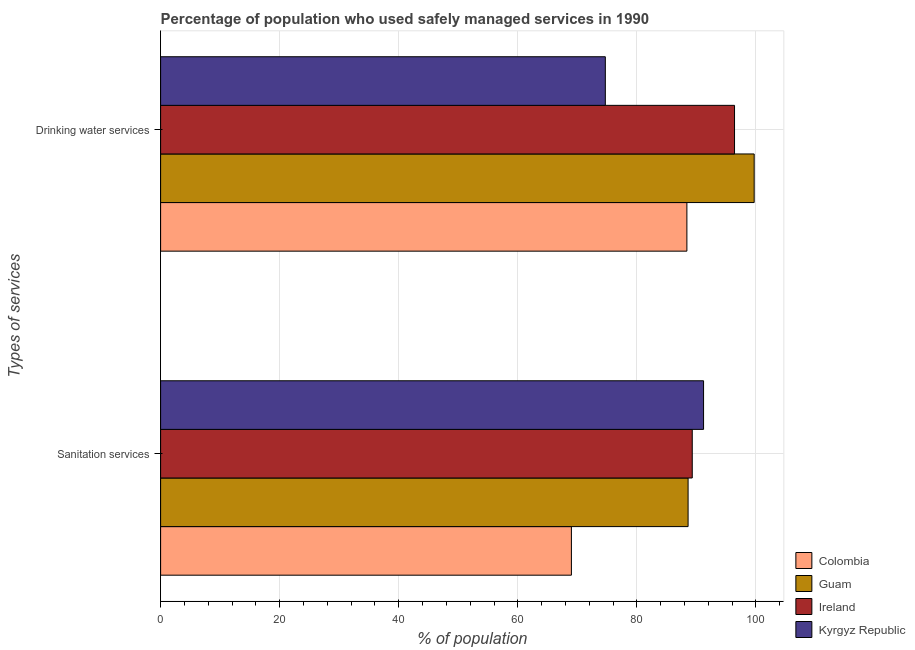How many groups of bars are there?
Keep it short and to the point. 2. How many bars are there on the 1st tick from the bottom?
Offer a terse response. 4. What is the label of the 1st group of bars from the top?
Give a very brief answer. Drinking water services. What is the percentage of population who used drinking water services in Kyrgyz Republic?
Ensure brevity in your answer.  74.7. Across all countries, what is the maximum percentage of population who used sanitation services?
Offer a terse response. 91.2. Across all countries, what is the minimum percentage of population who used drinking water services?
Offer a terse response. 74.7. In which country was the percentage of population who used sanitation services maximum?
Your answer should be compact. Kyrgyz Republic. In which country was the percentage of population who used drinking water services minimum?
Provide a short and direct response. Kyrgyz Republic. What is the total percentage of population who used sanitation services in the graph?
Ensure brevity in your answer.  338.1. What is the difference between the percentage of population who used drinking water services in Colombia and that in Ireland?
Keep it short and to the point. -8. What is the difference between the percentage of population who used sanitation services in Colombia and the percentage of population who used drinking water services in Guam?
Ensure brevity in your answer.  -30.7. What is the average percentage of population who used sanitation services per country?
Your response must be concise. 84.52. What is the difference between the percentage of population who used drinking water services and percentage of population who used sanitation services in Guam?
Your answer should be very brief. 11.1. What is the ratio of the percentage of population who used sanitation services in Ireland to that in Guam?
Your response must be concise. 1.01. In how many countries, is the percentage of population who used drinking water services greater than the average percentage of population who used drinking water services taken over all countries?
Your answer should be compact. 2. What does the 3rd bar from the top in Sanitation services represents?
Make the answer very short. Guam. What does the 3rd bar from the bottom in Sanitation services represents?
Offer a terse response. Ireland. How many countries are there in the graph?
Keep it short and to the point. 4. Are the values on the major ticks of X-axis written in scientific E-notation?
Offer a very short reply. No. Where does the legend appear in the graph?
Ensure brevity in your answer.  Bottom right. How many legend labels are there?
Offer a very short reply. 4. What is the title of the graph?
Ensure brevity in your answer.  Percentage of population who used safely managed services in 1990. Does "France" appear as one of the legend labels in the graph?
Give a very brief answer. No. What is the label or title of the X-axis?
Provide a succinct answer. % of population. What is the label or title of the Y-axis?
Offer a very short reply. Types of services. What is the % of population of Colombia in Sanitation services?
Your answer should be compact. 69. What is the % of population of Guam in Sanitation services?
Keep it short and to the point. 88.6. What is the % of population of Ireland in Sanitation services?
Provide a succinct answer. 89.3. What is the % of population in Kyrgyz Republic in Sanitation services?
Keep it short and to the point. 91.2. What is the % of population of Colombia in Drinking water services?
Provide a short and direct response. 88.4. What is the % of population of Guam in Drinking water services?
Your answer should be compact. 99.7. What is the % of population in Ireland in Drinking water services?
Provide a short and direct response. 96.4. What is the % of population of Kyrgyz Republic in Drinking water services?
Ensure brevity in your answer.  74.7. Across all Types of services, what is the maximum % of population in Colombia?
Your response must be concise. 88.4. Across all Types of services, what is the maximum % of population in Guam?
Provide a short and direct response. 99.7. Across all Types of services, what is the maximum % of population of Ireland?
Keep it short and to the point. 96.4. Across all Types of services, what is the maximum % of population of Kyrgyz Republic?
Your response must be concise. 91.2. Across all Types of services, what is the minimum % of population of Colombia?
Ensure brevity in your answer.  69. Across all Types of services, what is the minimum % of population of Guam?
Offer a very short reply. 88.6. Across all Types of services, what is the minimum % of population in Ireland?
Your response must be concise. 89.3. Across all Types of services, what is the minimum % of population in Kyrgyz Republic?
Make the answer very short. 74.7. What is the total % of population in Colombia in the graph?
Ensure brevity in your answer.  157.4. What is the total % of population of Guam in the graph?
Ensure brevity in your answer.  188.3. What is the total % of population of Ireland in the graph?
Your answer should be very brief. 185.7. What is the total % of population of Kyrgyz Republic in the graph?
Offer a very short reply. 165.9. What is the difference between the % of population of Colombia in Sanitation services and that in Drinking water services?
Ensure brevity in your answer.  -19.4. What is the difference between the % of population of Kyrgyz Republic in Sanitation services and that in Drinking water services?
Provide a short and direct response. 16.5. What is the difference between the % of population in Colombia in Sanitation services and the % of population in Guam in Drinking water services?
Give a very brief answer. -30.7. What is the difference between the % of population of Colombia in Sanitation services and the % of population of Ireland in Drinking water services?
Offer a terse response. -27.4. What is the difference between the % of population of Colombia in Sanitation services and the % of population of Kyrgyz Republic in Drinking water services?
Offer a terse response. -5.7. What is the average % of population of Colombia per Types of services?
Ensure brevity in your answer.  78.7. What is the average % of population in Guam per Types of services?
Keep it short and to the point. 94.15. What is the average % of population of Ireland per Types of services?
Give a very brief answer. 92.85. What is the average % of population in Kyrgyz Republic per Types of services?
Keep it short and to the point. 82.95. What is the difference between the % of population in Colombia and % of population in Guam in Sanitation services?
Provide a succinct answer. -19.6. What is the difference between the % of population in Colombia and % of population in Ireland in Sanitation services?
Offer a very short reply. -20.3. What is the difference between the % of population of Colombia and % of population of Kyrgyz Republic in Sanitation services?
Provide a succinct answer. -22.2. What is the difference between the % of population in Colombia and % of population in Guam in Drinking water services?
Keep it short and to the point. -11.3. What is the difference between the % of population of Colombia and % of population of Ireland in Drinking water services?
Your response must be concise. -8. What is the difference between the % of population in Colombia and % of population in Kyrgyz Republic in Drinking water services?
Give a very brief answer. 13.7. What is the difference between the % of population in Guam and % of population in Ireland in Drinking water services?
Provide a short and direct response. 3.3. What is the difference between the % of population of Ireland and % of population of Kyrgyz Republic in Drinking water services?
Your answer should be compact. 21.7. What is the ratio of the % of population in Colombia in Sanitation services to that in Drinking water services?
Provide a short and direct response. 0.78. What is the ratio of the % of population in Guam in Sanitation services to that in Drinking water services?
Offer a very short reply. 0.89. What is the ratio of the % of population in Ireland in Sanitation services to that in Drinking water services?
Keep it short and to the point. 0.93. What is the ratio of the % of population in Kyrgyz Republic in Sanitation services to that in Drinking water services?
Give a very brief answer. 1.22. What is the difference between the highest and the second highest % of population in Colombia?
Ensure brevity in your answer.  19.4. What is the difference between the highest and the second highest % of population of Guam?
Provide a short and direct response. 11.1. What is the difference between the highest and the second highest % of population in Ireland?
Offer a very short reply. 7.1. What is the difference between the highest and the lowest % of population in Guam?
Offer a terse response. 11.1. What is the difference between the highest and the lowest % of population in Ireland?
Ensure brevity in your answer.  7.1. What is the difference between the highest and the lowest % of population in Kyrgyz Republic?
Ensure brevity in your answer.  16.5. 